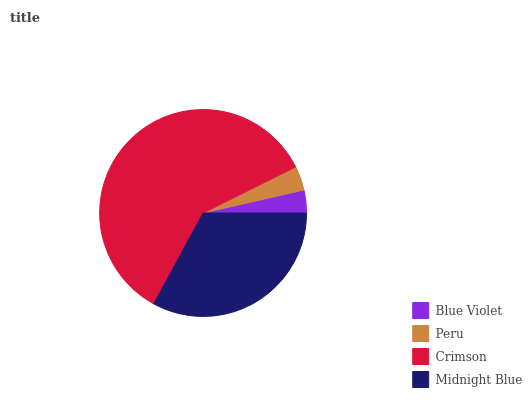Is Blue Violet the minimum?
Answer yes or no. Yes. Is Crimson the maximum?
Answer yes or no. Yes. Is Peru the minimum?
Answer yes or no. No. Is Peru the maximum?
Answer yes or no. No. Is Peru greater than Blue Violet?
Answer yes or no. Yes. Is Blue Violet less than Peru?
Answer yes or no. Yes. Is Blue Violet greater than Peru?
Answer yes or no. No. Is Peru less than Blue Violet?
Answer yes or no. No. Is Midnight Blue the high median?
Answer yes or no. Yes. Is Peru the low median?
Answer yes or no. Yes. Is Crimson the high median?
Answer yes or no. No. Is Blue Violet the low median?
Answer yes or no. No. 